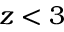Convert formula to latex. <formula><loc_0><loc_0><loc_500><loc_500>z < 3</formula> 